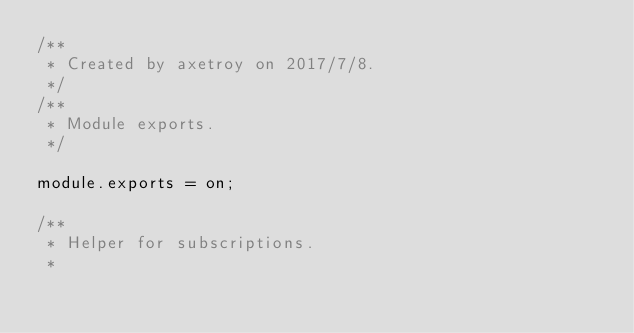Convert code to text. <code><loc_0><loc_0><loc_500><loc_500><_JavaScript_>/**
 * Created by axetroy on 2017/7/8.
 */
/**
 * Module exports.
 */

module.exports = on;

/**
 * Helper for subscriptions.
 *</code> 